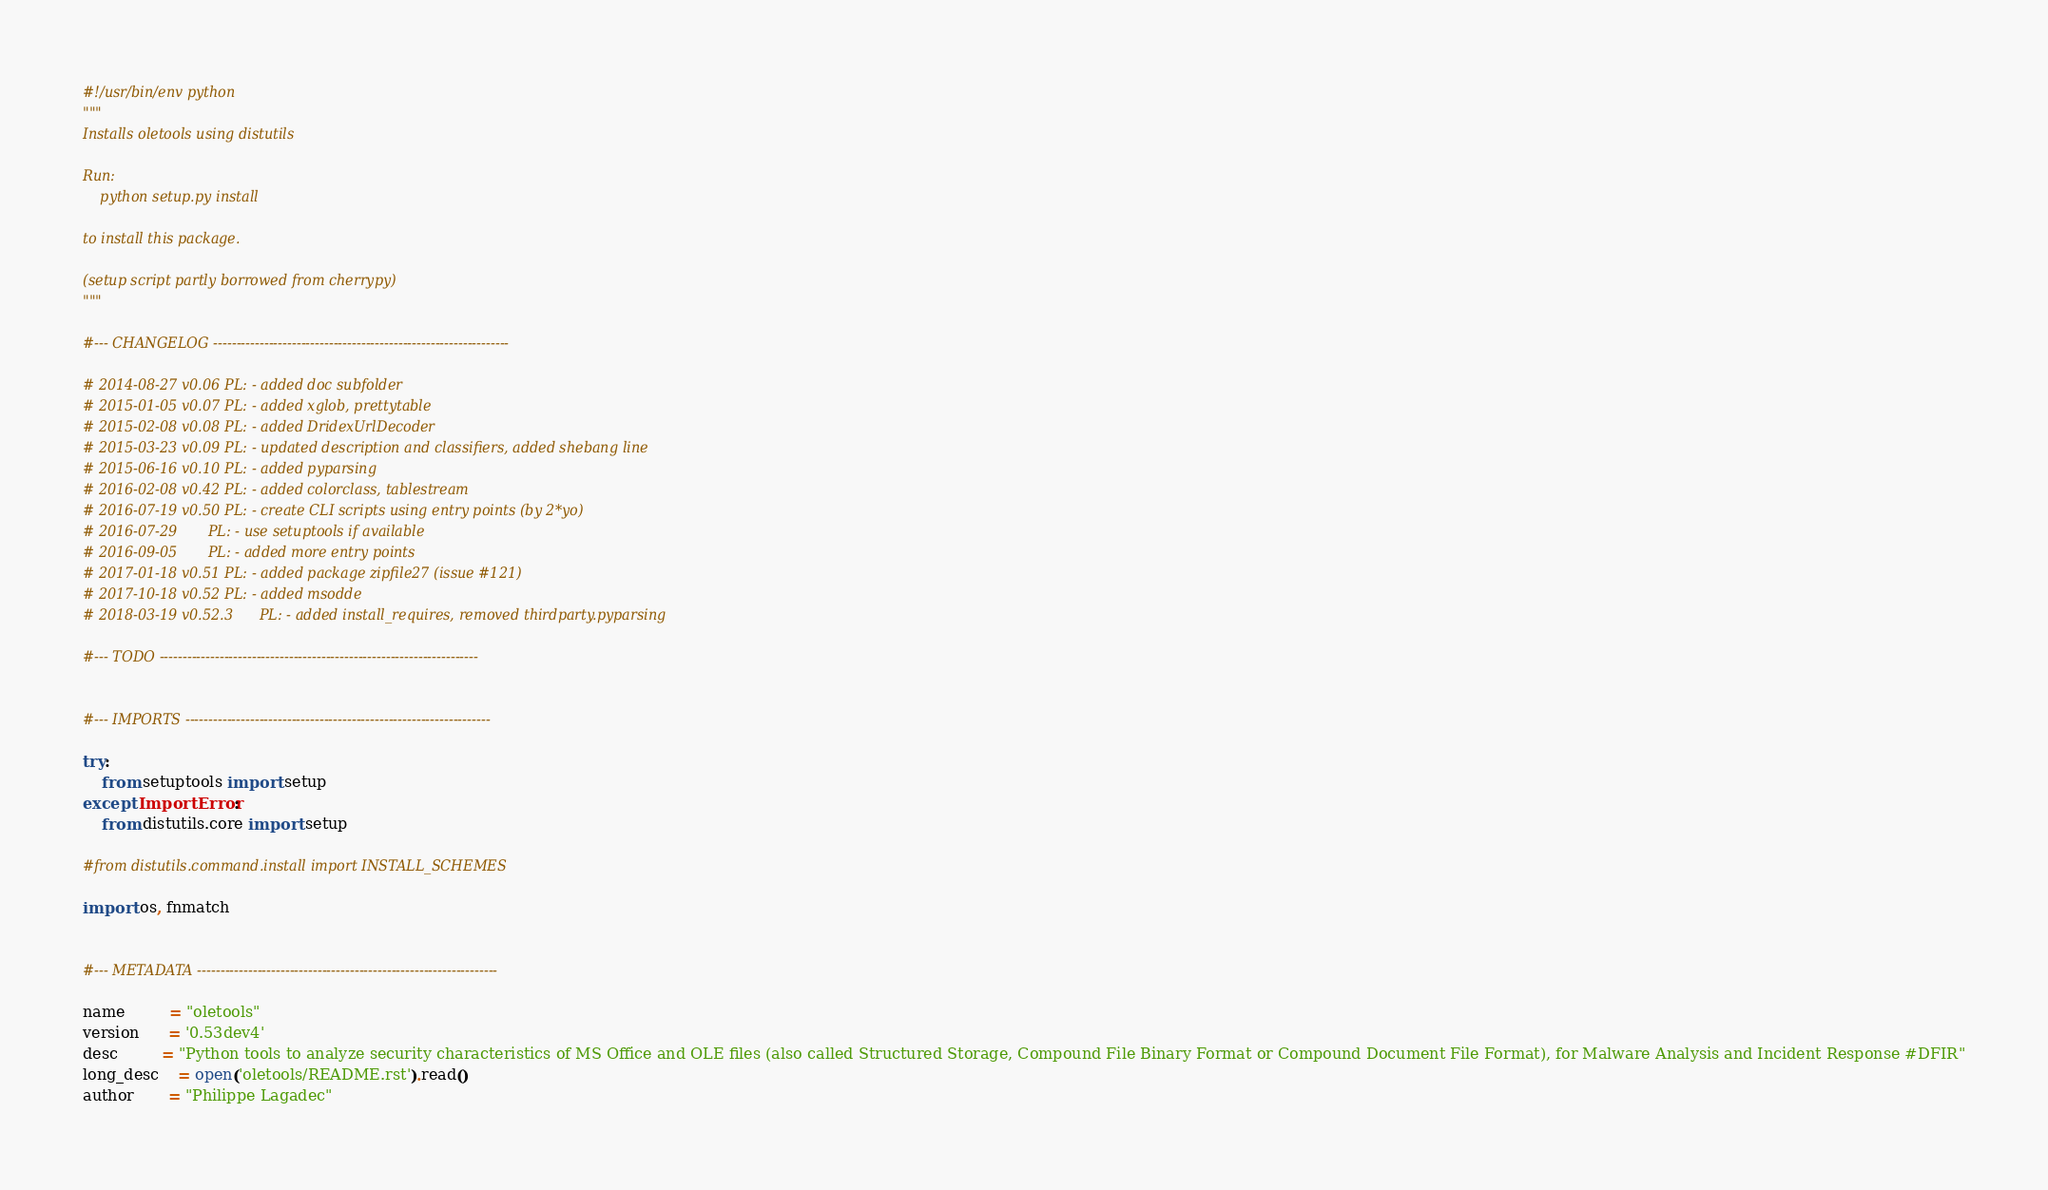Convert code to text. <code><loc_0><loc_0><loc_500><loc_500><_Python_>#!/usr/bin/env python
"""
Installs oletools using distutils

Run:
    python setup.py install

to install this package.

(setup script partly borrowed from cherrypy)
"""

#--- CHANGELOG ----------------------------------------------------------------

# 2014-08-27 v0.06 PL: - added doc subfolder
# 2015-01-05 v0.07 PL: - added xglob, prettytable
# 2015-02-08 v0.08 PL: - added DridexUrlDecoder
# 2015-03-23 v0.09 PL: - updated description and classifiers, added shebang line
# 2015-06-16 v0.10 PL: - added pyparsing
# 2016-02-08 v0.42 PL: - added colorclass, tablestream
# 2016-07-19 v0.50 PL: - create CLI scripts using entry points (by 2*yo)
# 2016-07-29       PL: - use setuptools if available
# 2016-09-05       PL: - added more entry points
# 2017-01-18 v0.51 PL: - added package zipfile27 (issue #121)
# 2017-10-18 v0.52 PL: - added msodde
# 2018-03-19 v0.52.3      PL: - added install_requires, removed thirdparty.pyparsing

#--- TODO ---------------------------------------------------------------------


#--- IMPORTS ------------------------------------------------------------------

try:
    from setuptools import setup
except ImportError:
    from distutils.core import setup

#from distutils.command.install import INSTALL_SCHEMES

import os, fnmatch


#--- METADATA -----------------------------------------------------------------

name         = "oletools"
version      = '0.53dev4'
desc         = "Python tools to analyze security characteristics of MS Office and OLE files (also called Structured Storage, Compound File Binary Format or Compound Document File Format), for Malware Analysis and Incident Response #DFIR"
long_desc    = open('oletools/README.rst').read()
author       = "Philippe Lagadec"</code> 